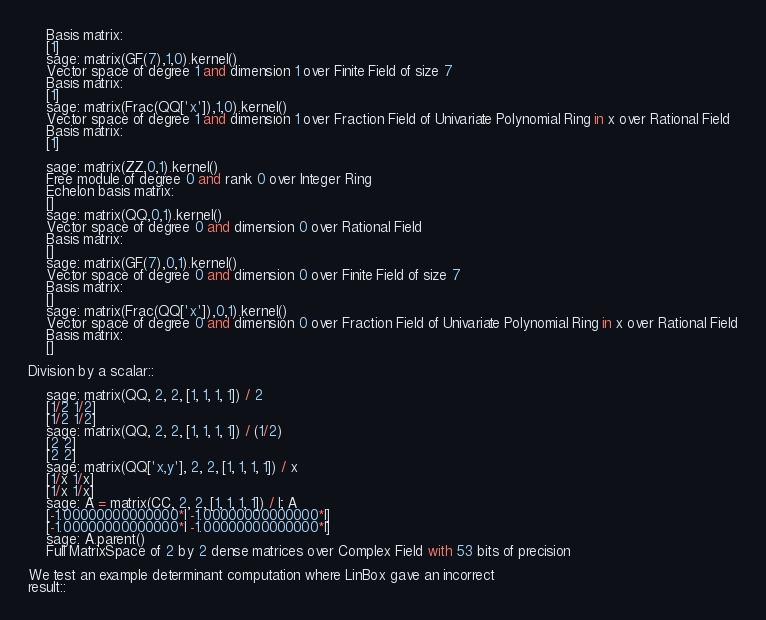<code> <loc_0><loc_0><loc_500><loc_500><_Python_>    Basis matrix:
    [1]
    sage: matrix(GF(7),1,0).kernel()
    Vector space of degree 1 and dimension 1 over Finite Field of size 7
    Basis matrix:
    [1]
    sage: matrix(Frac(QQ['x']),1,0).kernel()
    Vector space of degree 1 and dimension 1 over Fraction Field of Univariate Polynomial Ring in x over Rational Field
    Basis matrix:
    [1]

    sage: matrix(ZZ,0,1).kernel()
    Free module of degree 0 and rank 0 over Integer Ring
    Echelon basis matrix:
    []
    sage: matrix(QQ,0,1).kernel()
    Vector space of degree 0 and dimension 0 over Rational Field
    Basis matrix:
    []
    sage: matrix(GF(7),0,1).kernel()
    Vector space of degree 0 and dimension 0 over Finite Field of size 7
    Basis matrix:
    []
    sage: matrix(Frac(QQ['x']),0,1).kernel()
    Vector space of degree 0 and dimension 0 over Fraction Field of Univariate Polynomial Ring in x over Rational Field
    Basis matrix:
    []

Division by a scalar::

    sage: matrix(QQ, 2, 2, [1, 1, 1, 1]) / 2
    [1/2 1/2]
    [1/2 1/2]
    sage: matrix(QQ, 2, 2, [1, 1, 1, 1]) / (1/2)
    [2 2]
    [2 2]
    sage: matrix(QQ['x,y'], 2, 2, [1, 1, 1, 1]) / x
    [1/x 1/x]
    [1/x 1/x]
    sage: A = matrix(CC, 2, 2, [1, 1, 1, 1]) / I; A
    [-1.00000000000000*I -1.00000000000000*I]
    [-1.00000000000000*I -1.00000000000000*I]
    sage: A.parent()
    Full MatrixSpace of 2 by 2 dense matrices over Complex Field with 53 bits of precision

We test an example determinant computation where LinBox gave an incorrect
result::
</code> 